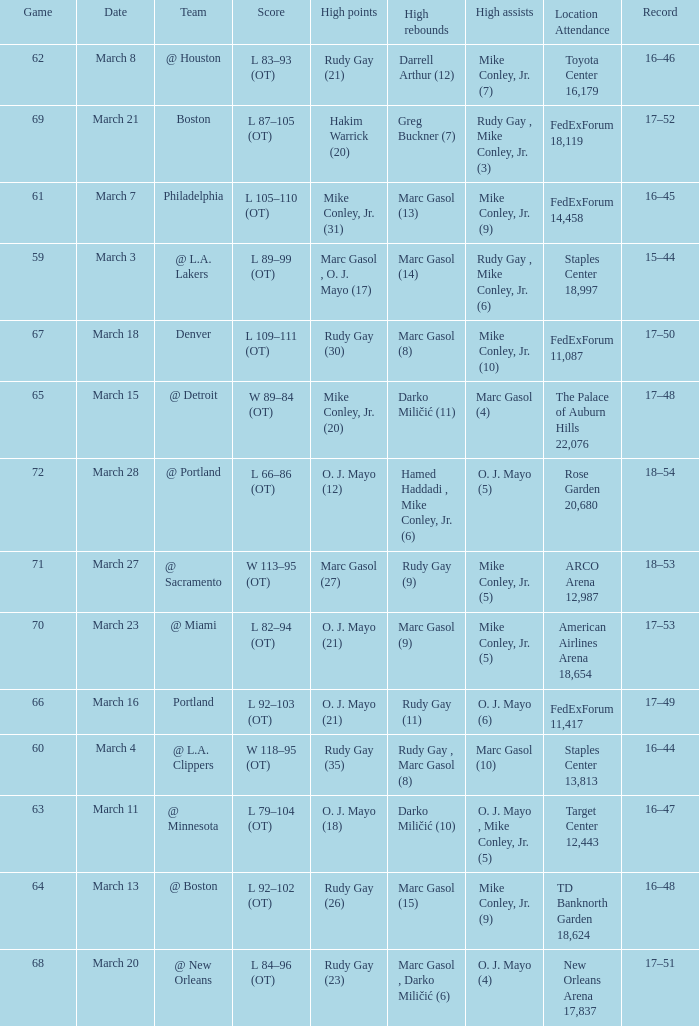What was the location and attendance for game 60? Staples Center 13,813. 